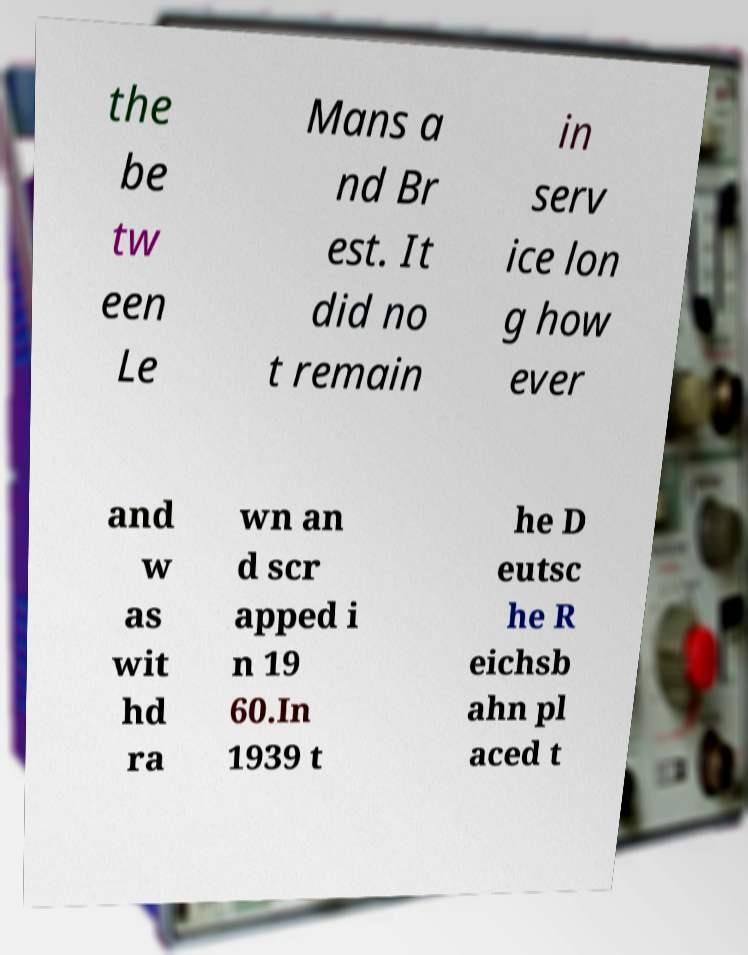Can you read and provide the text displayed in the image?This photo seems to have some interesting text. Can you extract and type it out for me? the be tw een Le Mans a nd Br est. It did no t remain in serv ice lon g how ever and w as wit hd ra wn an d scr apped i n 19 60.In 1939 t he D eutsc he R eichsb ahn pl aced t 